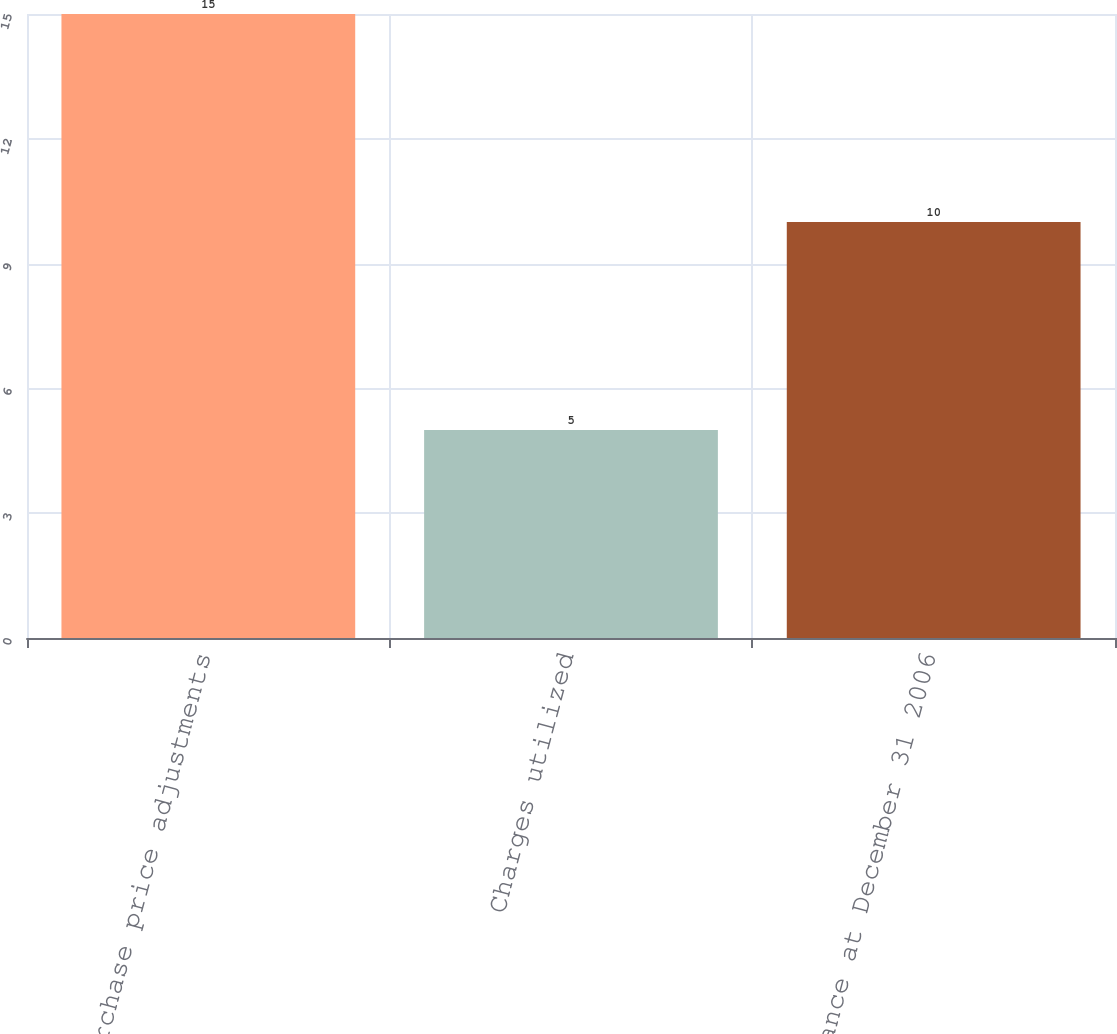Convert chart. <chart><loc_0><loc_0><loc_500><loc_500><bar_chart><fcel>Purchase price adjustments<fcel>Charges utilized<fcel>Balance at December 31 2006<nl><fcel>15<fcel>5<fcel>10<nl></chart> 